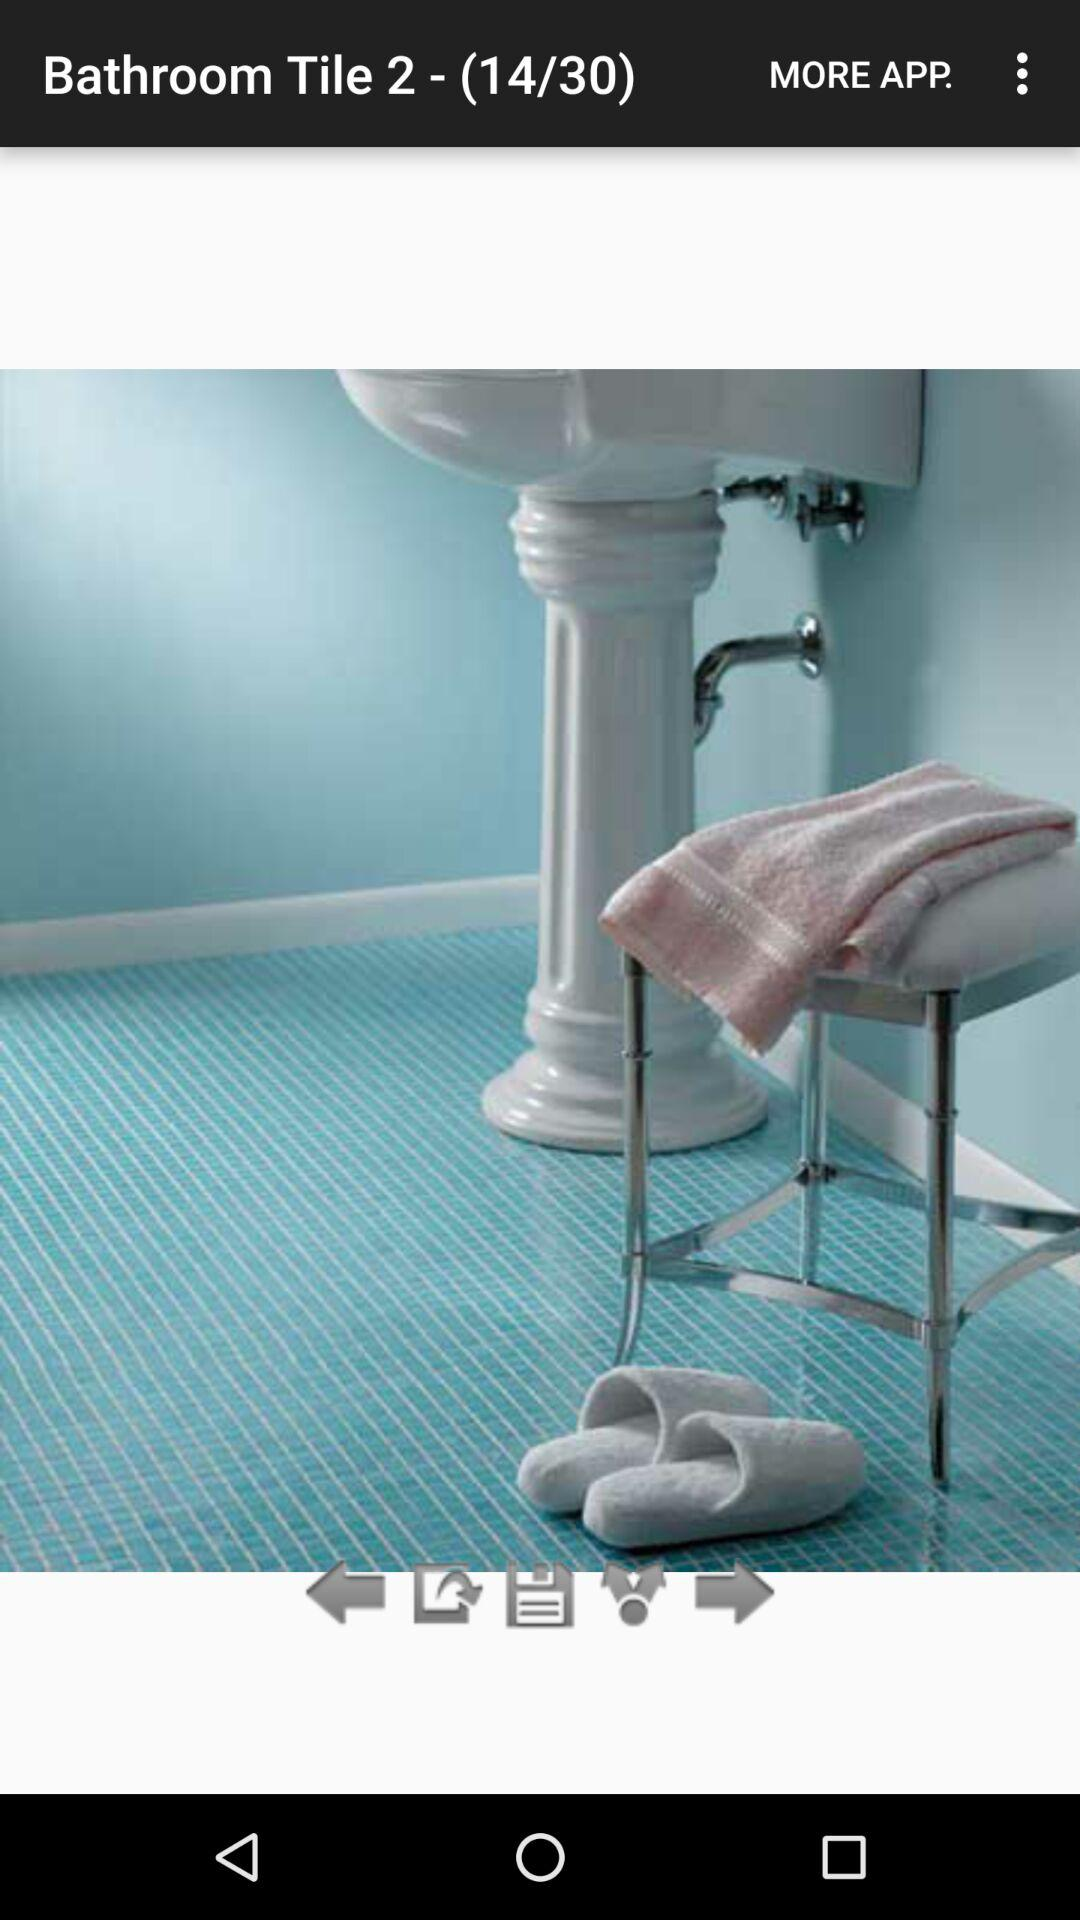What is the total number of the slides? The total number of slides is 30. 